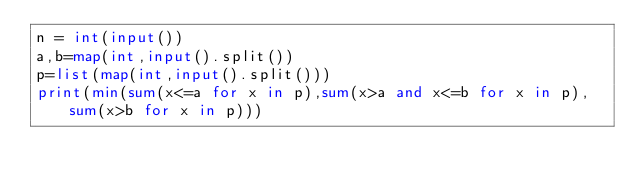<code> <loc_0><loc_0><loc_500><loc_500><_Python_>n = int(input())
a,b=map(int,input().split())
p=list(map(int,input().split()))
print(min(sum(x<=a for x in p),sum(x>a and x<=b for x in p),sum(x>b for x in p)))
</code> 